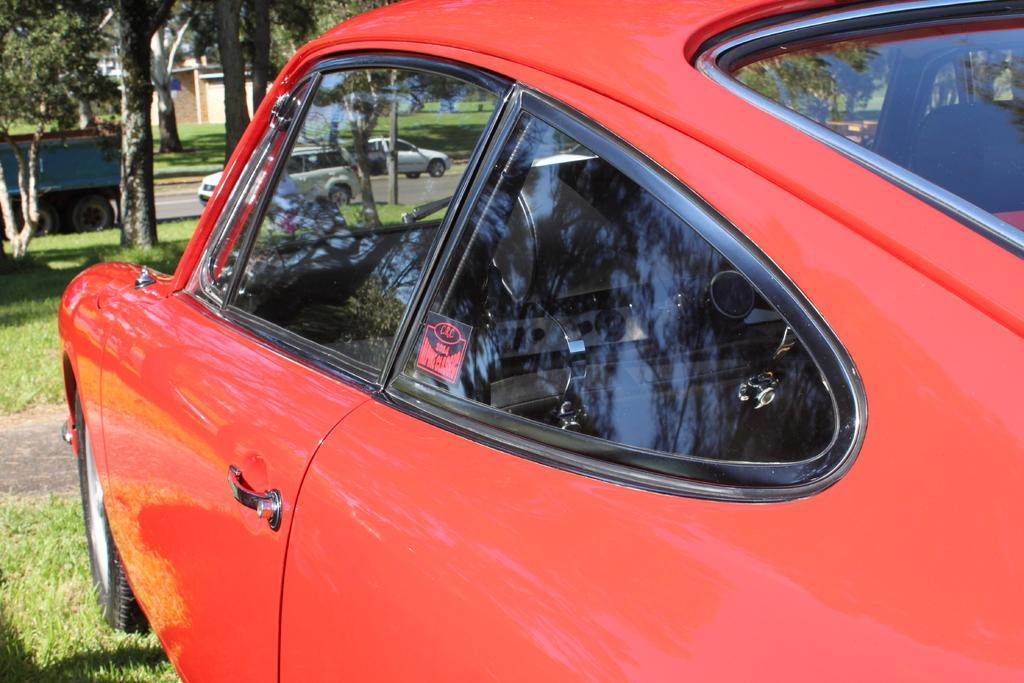Please provide a concise description of this image. In this image we can see a car. On the ground there is grass. In the background there are trees, road, vehicles and building 